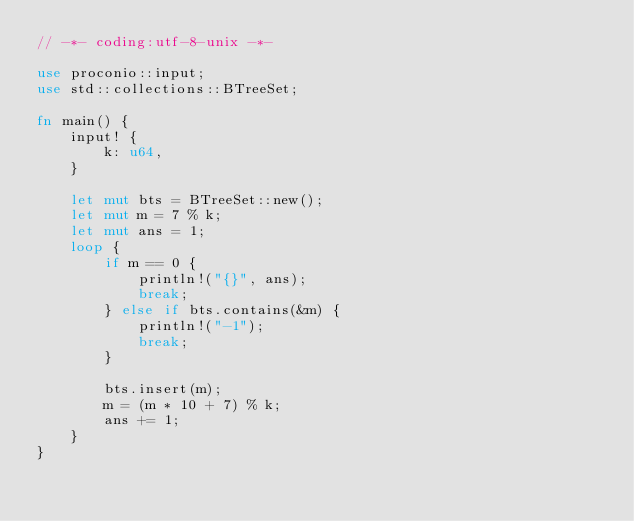Convert code to text. <code><loc_0><loc_0><loc_500><loc_500><_Rust_>// -*- coding:utf-8-unix -*-

use proconio::input;
use std::collections::BTreeSet;

fn main() {
    input! {
        k: u64,
    }

    let mut bts = BTreeSet::new();
    let mut m = 7 % k;
    let mut ans = 1;
    loop {
        if m == 0 {
            println!("{}", ans);
            break;
        } else if bts.contains(&m) {
            println!("-1");
            break;
        }

        bts.insert(m);
        m = (m * 10 + 7) % k;
        ans += 1;
    }
}
</code> 